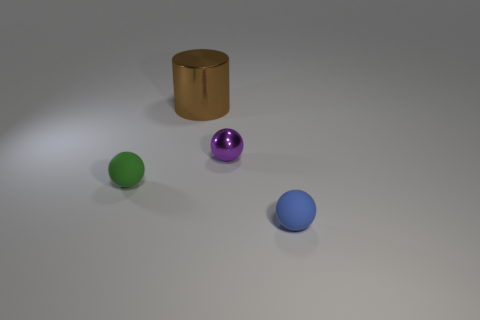There is a green sphere that is the same size as the blue matte ball; what is its material?
Your response must be concise. Rubber. Is there a tiny blue thing of the same shape as the big brown object?
Your answer should be compact. No. There is a small object in front of the tiny green matte ball; what shape is it?
Provide a succinct answer. Sphere. How many tiny blue cubes are there?
Make the answer very short. 0. There is a sphere that is made of the same material as the large brown object; what color is it?
Give a very brief answer. Purple. How many big objects are spheres or gray metallic spheres?
Your answer should be very brief. 0. There is a tiny purple shiny object; what number of small purple spheres are to the right of it?
Give a very brief answer. 0. The other rubber object that is the same shape as the tiny blue thing is what color?
Your answer should be very brief. Green. What number of shiny objects are either small green balls or cyan objects?
Make the answer very short. 0. Are there any purple shiny objects that are in front of the tiny rubber object that is in front of the tiny thing to the left of the big brown metal object?
Your answer should be very brief. No. 